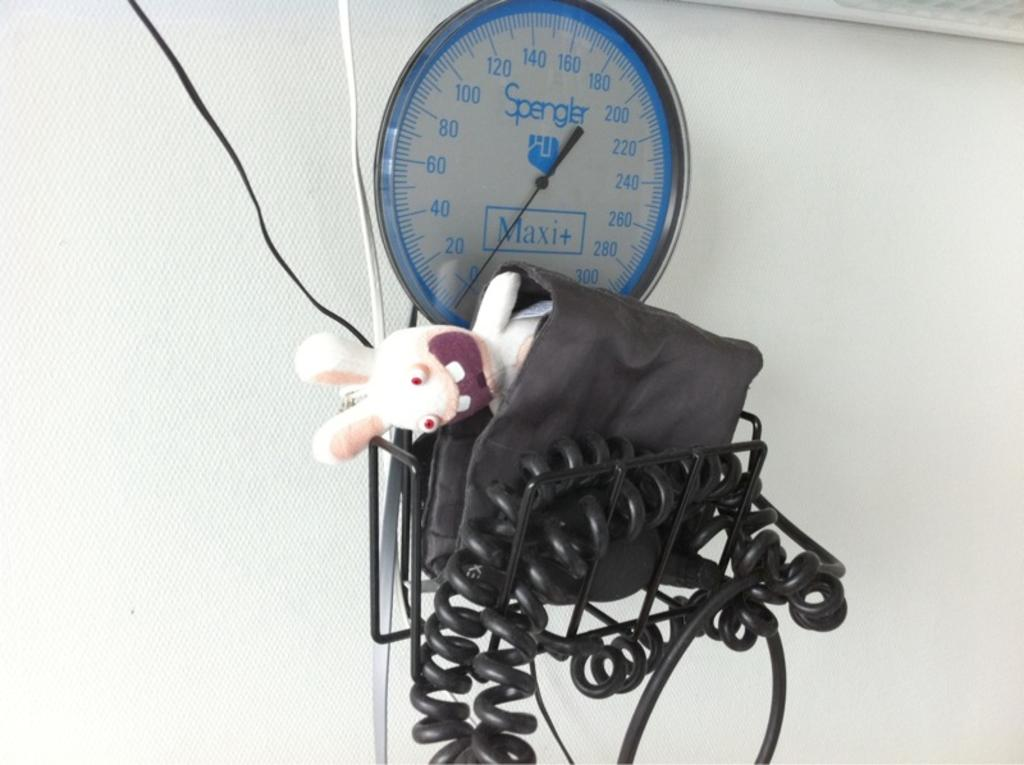What is the main object in the image? There is a weighing machine in the image. What is placed on the weighing machine? There is a doll on the weighing machine. What else can be seen in the image besides the weighing machine and the doll? There is a wire and a black color object that looks like a bag in the image. What is visible in the background of the image? There is a wall in the background of the image. Who is the owner of the ticket seen in the image? There is no ticket present in the image. What is the temperature of the heat source in the image? There is no heat source present in the image. 